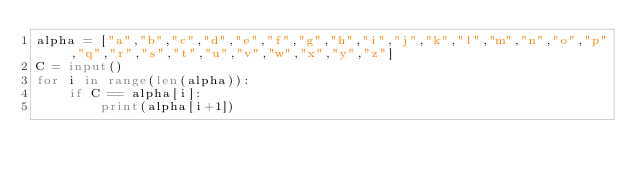Convert code to text. <code><loc_0><loc_0><loc_500><loc_500><_Python_>alpha = ["a","b","c","d","e","f","g","h","i","j","k","l","m","n","o","p","q","r","s","t","u","v","w","x","y","z"]
C = input()
for i in range(len(alpha)):
    if C == alpha[i]:
        print(alpha[i+1])</code> 